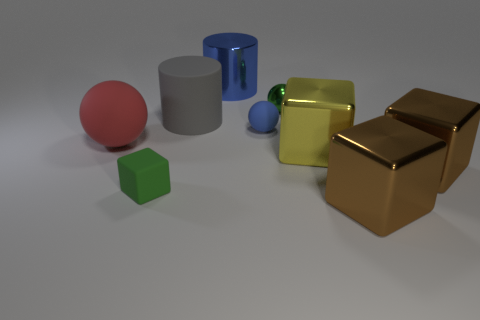Are there fewer big shiny cylinders that are in front of the small metal object than big gray things in front of the gray thing?
Make the answer very short. No. What number of things are large brown metal cylinders or objects that are behind the big red matte ball?
Offer a terse response. 4. What material is the gray thing that is the same size as the red sphere?
Offer a terse response. Rubber. Do the small blue sphere and the large yellow block have the same material?
Make the answer very short. No. There is a large thing that is both behind the tiny blue thing and in front of the green sphere; what color is it?
Make the answer very short. Gray. Does the big metallic object behind the gray cylinder have the same color as the small rubber ball?
Your response must be concise. Yes. There is a red object that is the same size as the yellow metallic cube; what shape is it?
Your answer should be very brief. Sphere. What number of other things are the same color as the big shiny cylinder?
Make the answer very short. 1. What number of other objects are the same material as the big sphere?
Give a very brief answer. 3. Is the size of the gray rubber cylinder the same as the blue shiny object that is on the right side of the large ball?
Keep it short and to the point. Yes. 